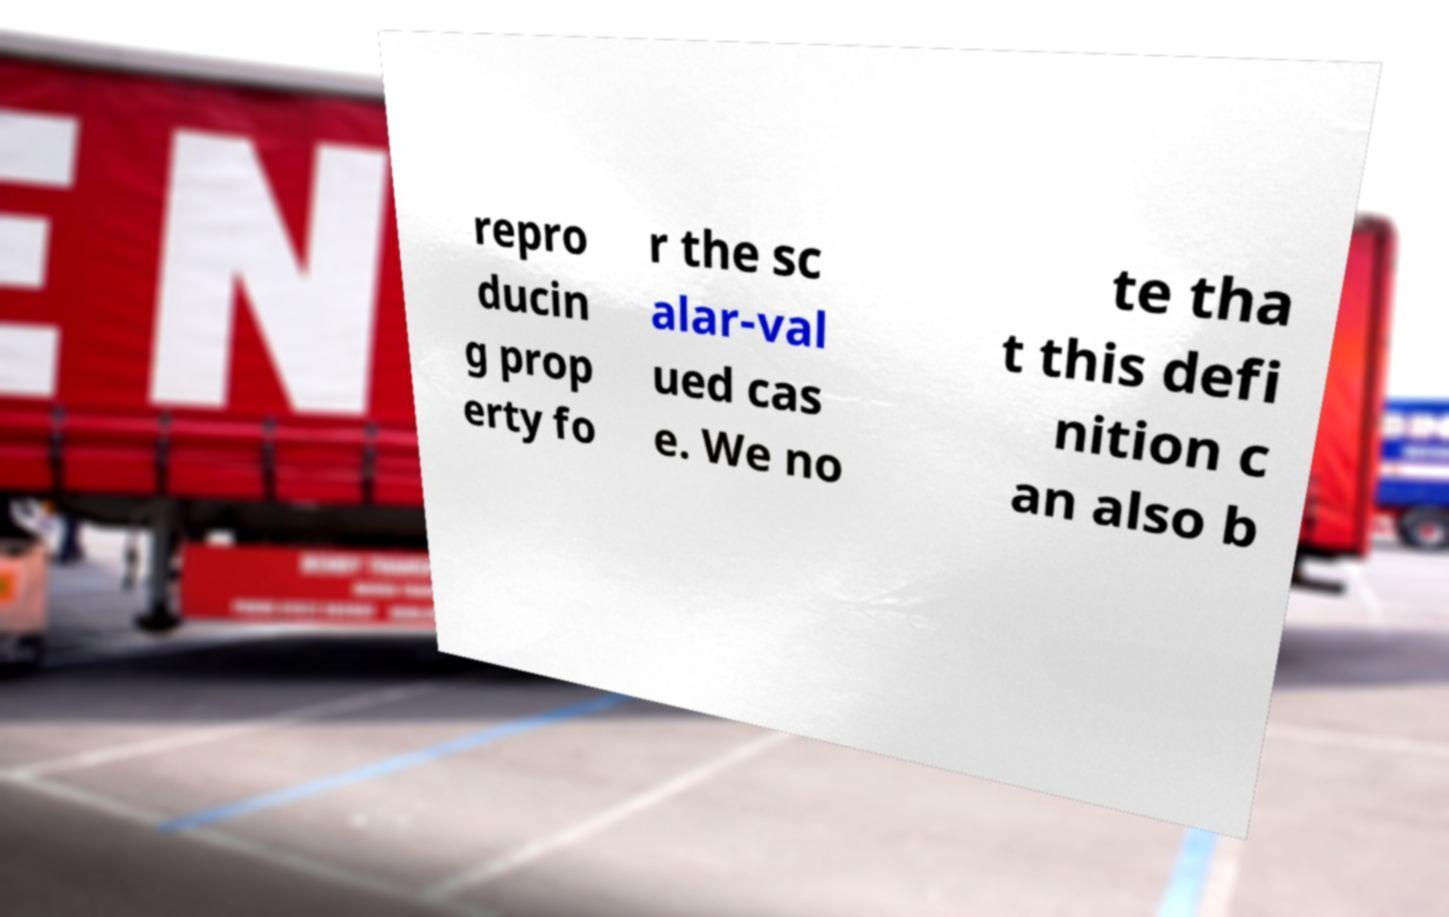I need the written content from this picture converted into text. Can you do that? repro ducin g prop erty fo r the sc alar-val ued cas e. We no te tha t this defi nition c an also b 